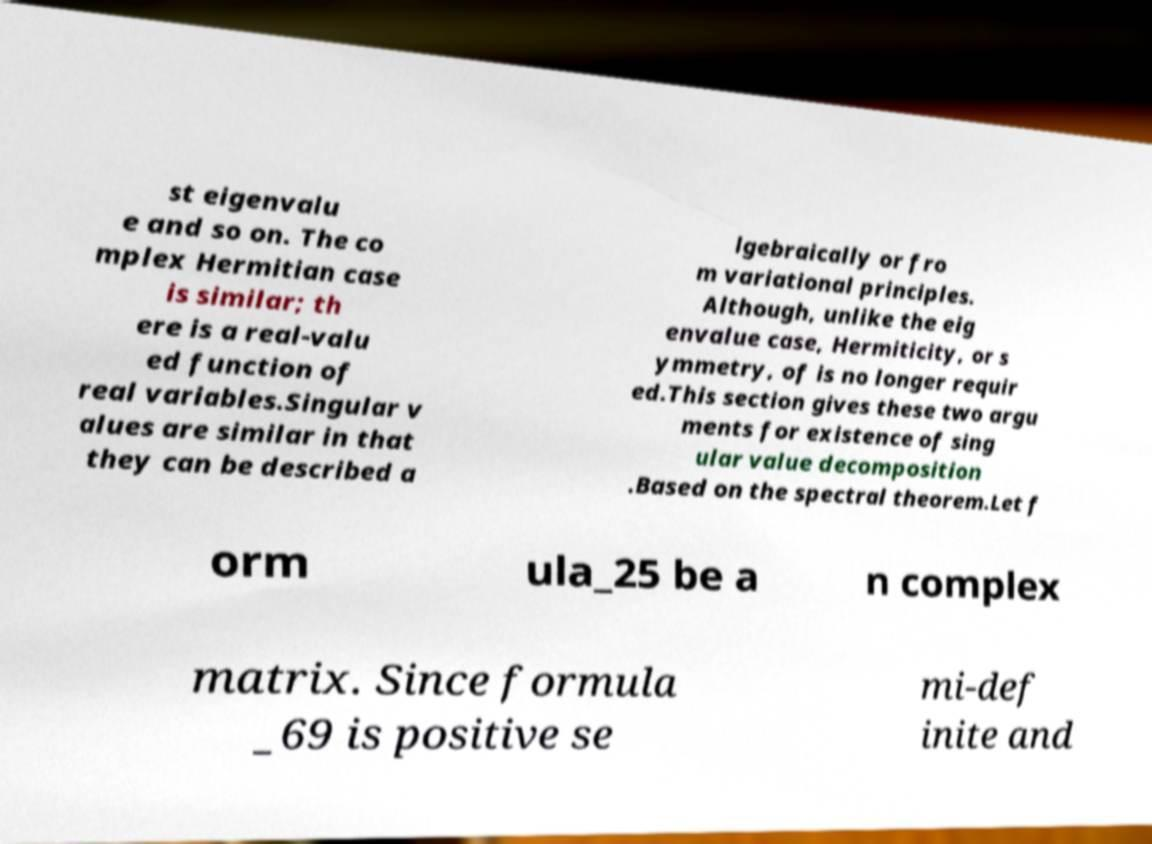Can you read and provide the text displayed in the image?This photo seems to have some interesting text. Can you extract and type it out for me? st eigenvalu e and so on. The co mplex Hermitian case is similar; th ere is a real-valu ed function of real variables.Singular v alues are similar in that they can be described a lgebraically or fro m variational principles. Although, unlike the eig envalue case, Hermiticity, or s ymmetry, of is no longer requir ed.This section gives these two argu ments for existence of sing ular value decomposition .Based on the spectral theorem.Let f orm ula_25 be a n complex matrix. Since formula _69 is positive se mi-def inite and 